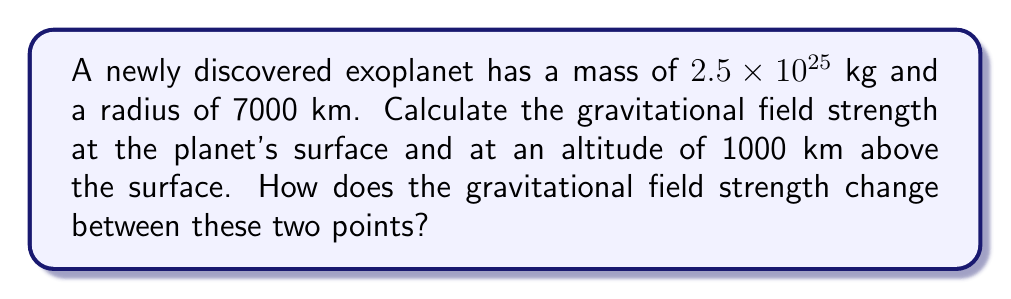Provide a solution to this math problem. To solve this problem, we'll use the gravitational field strength equation:

$$g = \frac{GM}{r^2}$$

Where:
$g$ is the gravitational field strength (m/s²)
$G$ is the gravitational constant ($6.67 \times 10^{-11}$ N⋅m²/kg²)
$M$ is the mass of the planet (kg)
$r$ is the distance from the center of the planet (m)

Step 1: Calculate the gravitational field strength at the surface.
$r_{\text{surface}} = 7000$ km $= 7 \times 10^6$ m
$$g_{\text{surface}} = \frac{(6.67 \times 10^{-11})(2.5 \times 10^{25})}{(7 \times 10^6)^2} = 34.01 \text{ m/s²}$$

Step 2: Calculate the gravitational field strength at 1000 km above the surface.
$r_{\text{altitude}} = (7000 + 1000)$ km $= 8 \times 10^6$ m
$$g_{\text{altitude}} = \frac{(6.67 \times 10^{-11})(2.5 \times 10^{25})}{(8 \times 10^6)^2} = 26.04 \text{ m/s²}$$

Step 3: Calculate the change in gravitational field strength.
$$\Delta g = g_{\text{surface}} - g_{\text{altitude}} = 34.01 - 26.04 = 7.97 \text{ m/s²}$$

Step 4: Calculate the percentage change.
$$\text{Percentage change} = \frac{\Delta g}{g_{\text{surface}}} \times 100\% = \frac{7.97}{34.01} \times 100\% = 23.43\%$$

The gravitational field strength decreases by 23.43% between the surface and 1000 km altitude.
Answer: Surface: 34.01 m/s²; 1000 km altitude: 26.04 m/s²; 23.43% decrease 